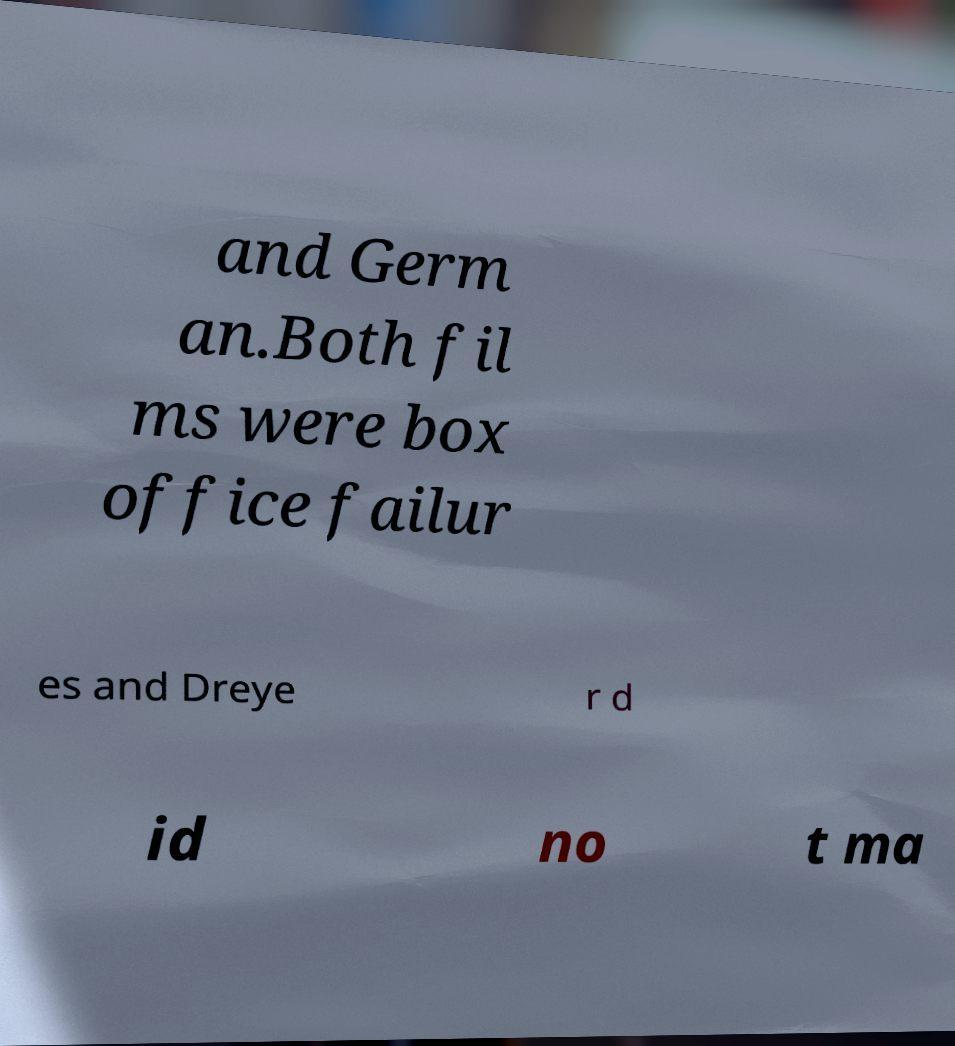Could you extract and type out the text from this image? and Germ an.Both fil ms were box office failur es and Dreye r d id no t ma 